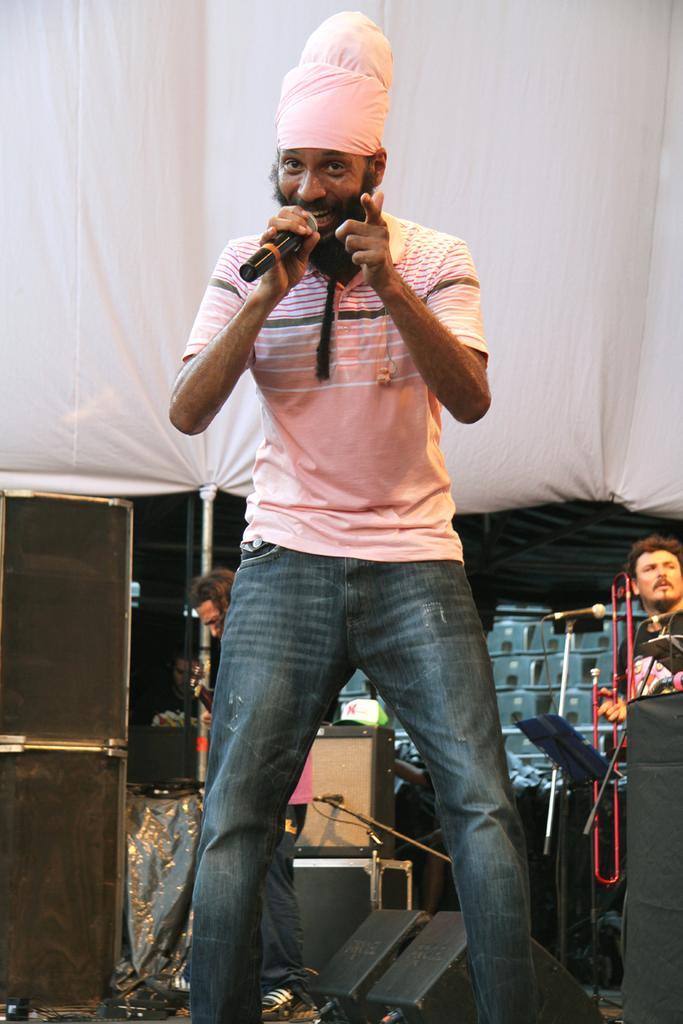Describe this image in one or two sentences. In this picture there is a man standing and holding a mic in his hand , singing. There are three men who are standing at the background. There is a loudspeaker and few other objects. 